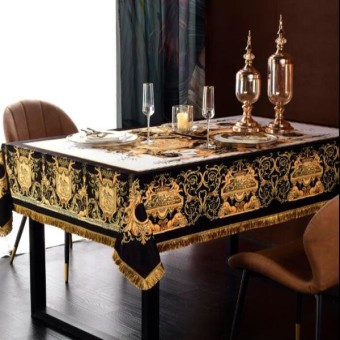What style does the dining table decor suggest? The dining table decor suggests a baroque-style opulence, with its richly patterned tablecloth, gilded edges, and ornamental candelabras. The overall atmosphere appears to be formal and ornate, reminiscent of classical luxury. 